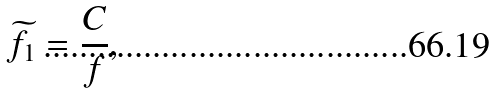<formula> <loc_0><loc_0><loc_500><loc_500>\widetilde { f } _ { 1 } = \frac { C } { f } ,</formula> 